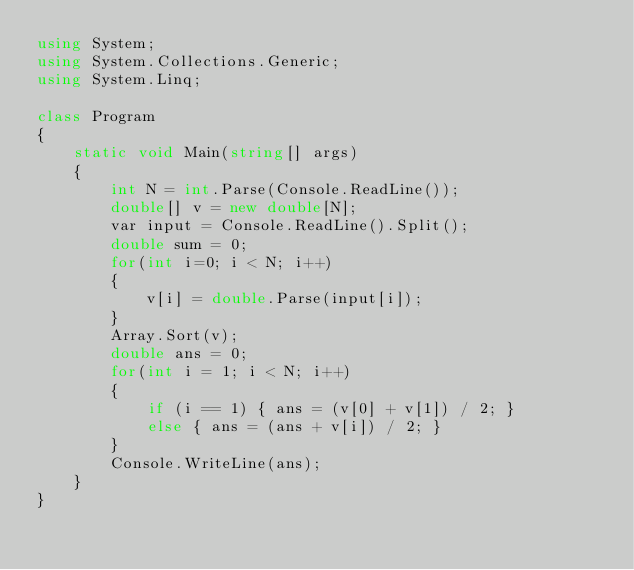<code> <loc_0><loc_0><loc_500><loc_500><_C#_>using System;
using System.Collections.Generic;
using System.Linq;

class Program
{
    static void Main(string[] args)
    {
        int N = int.Parse(Console.ReadLine());
        double[] v = new double[N];
        var input = Console.ReadLine().Split();
        double sum = 0;
        for(int i=0; i < N; i++)
        {
            v[i] = double.Parse(input[i]);
        }
        Array.Sort(v);
        double ans = 0;
        for(int i = 1; i < N; i++)
        {
            if (i == 1) { ans = (v[0] + v[1]) / 2; }
            else { ans = (ans + v[i]) / 2; }
        }
        Console.WriteLine(ans);
    }
}
</code> 